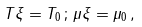Convert formula to latex. <formula><loc_0><loc_0><loc_500><loc_500>T \xi = T _ { 0 } \, ; \, \mu \xi = \mu _ { 0 } \, ,</formula> 